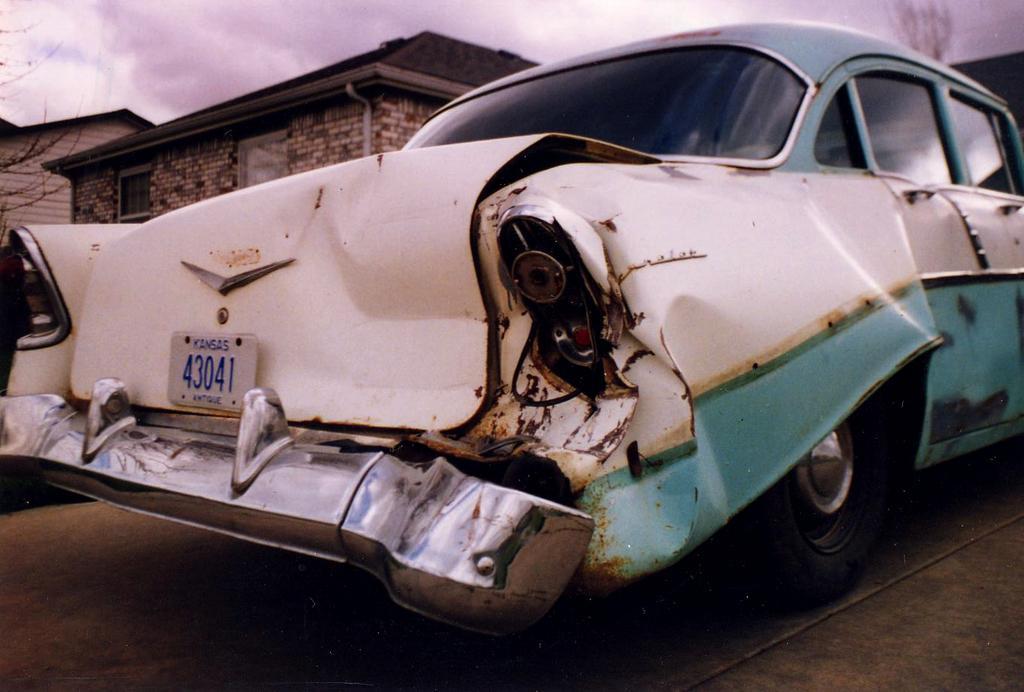Describe this image in one or two sentences. In this image there is a car parked on the road. The rear part of the car is damaged. Behind the car there are houses. At the top there is the sky. 